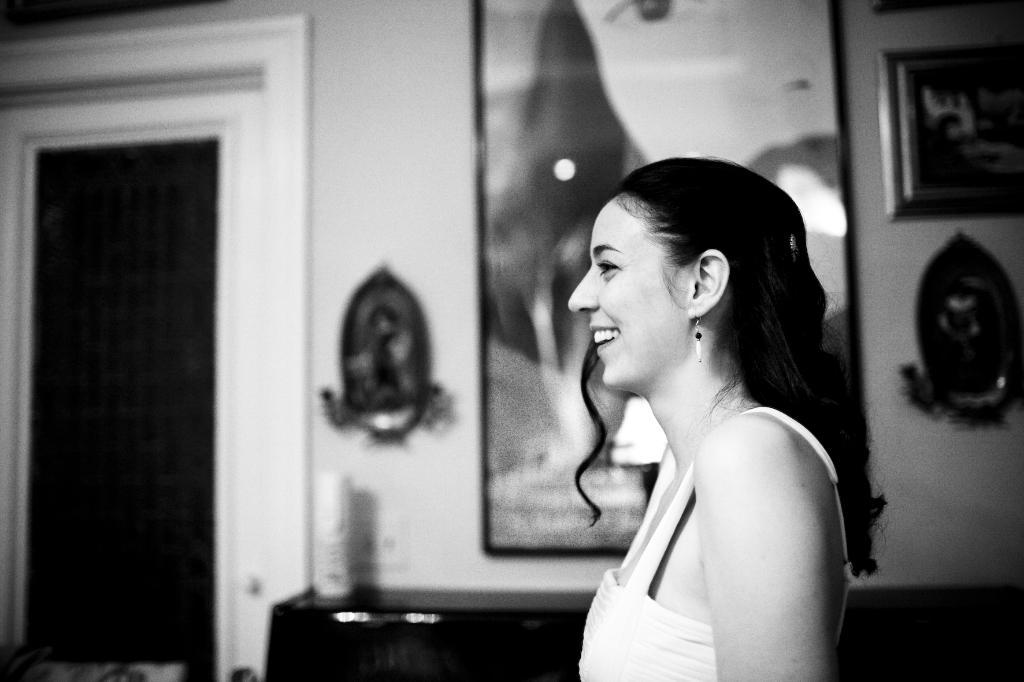What is the main subject of the image? There is a person standing in the image. What can be seen on the wall in the background? There are frames attached to the wall in the background. What architectural feature is visible in the background? There is a door in the background. What color scheme is used in the image? The image is in black and white. What type of cloud can be seen in the image? There are no clouds visible in the image, as it is in black and white and does not depict any outdoor scenes. 